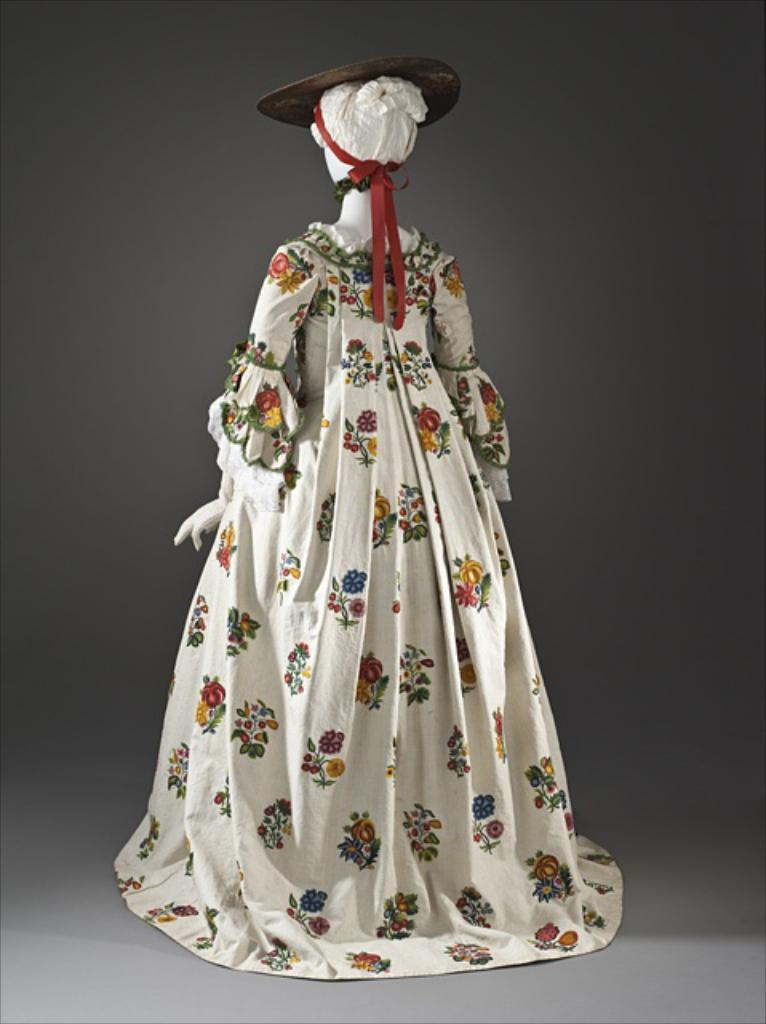What is the main subject of the image? There is a mannequin in the image. What is the mannequin wearing? The mannequin is wearing a woman's dress. Can you describe the dress? The dress has designs on it. What is on top of the mannequin's head? There is a hat on top of the mannequin. What color is the ribbon on the hat? The hat has a red color ribbon tied to it. How many deer can be seen in the image? There are no deer present in the image. Can you tell me how to play chess using the mannequin in the image? The image does not depict a chess game or any chess pieces, so it cannot be used to demonstrate how to play chess. 